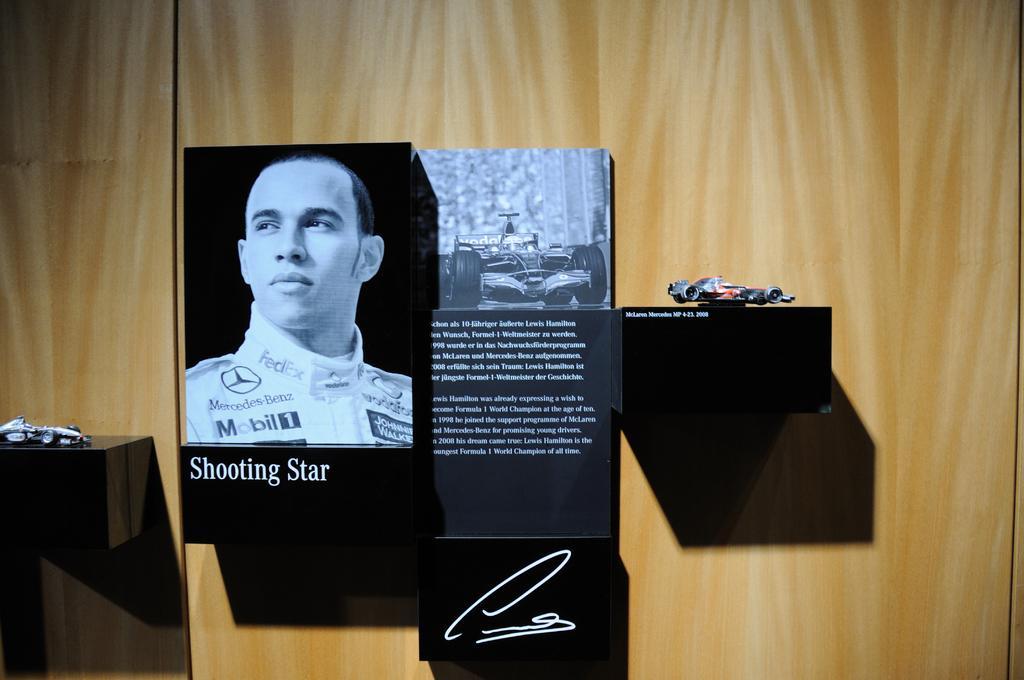How would you summarize this image in a sentence or two? In this picture we can see the boards are present to the wall and also we can see the shelves. On shelves we can see the toys. 